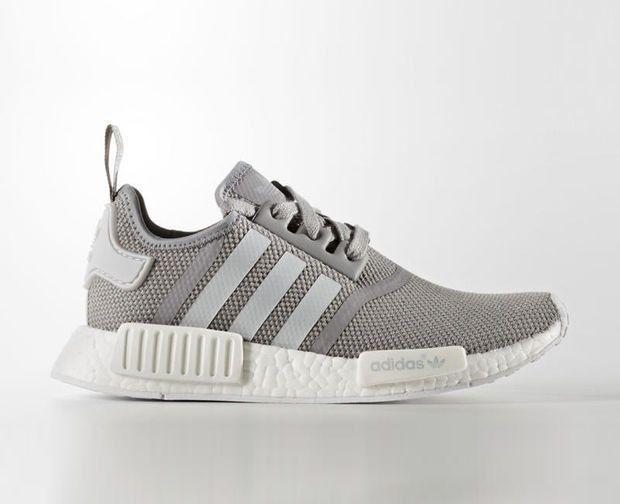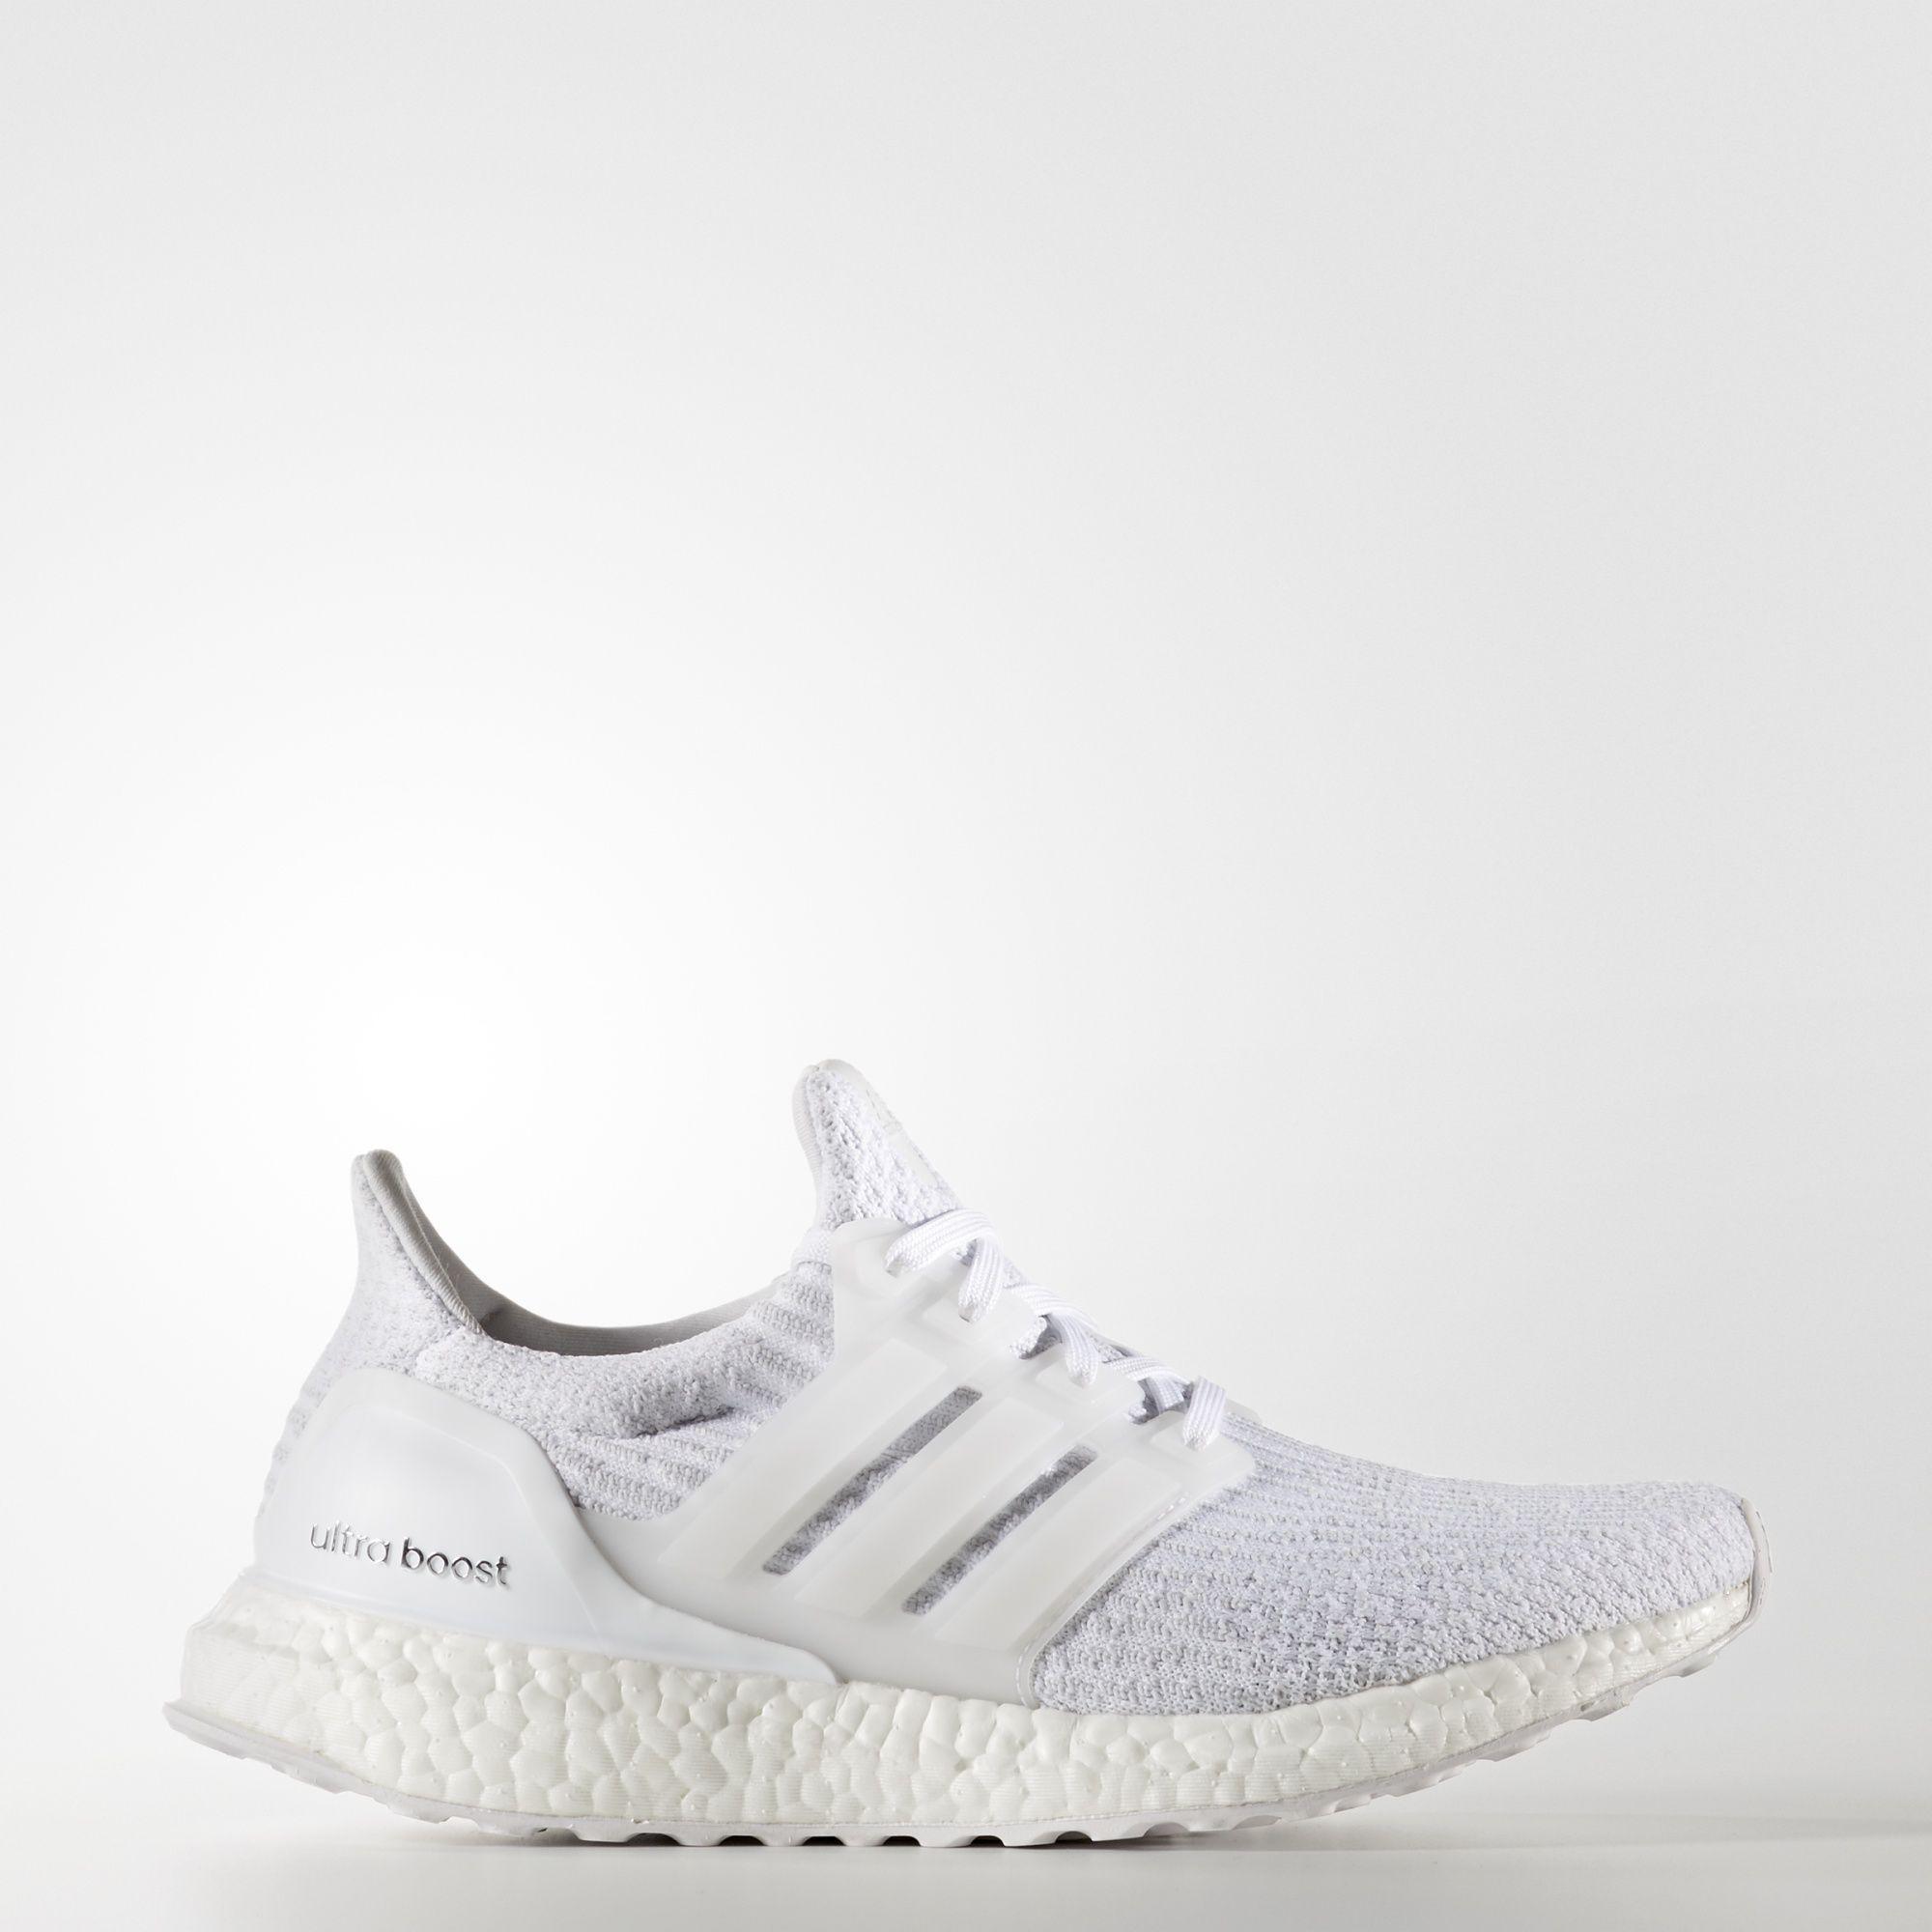The first image is the image on the left, the second image is the image on the right. Analyze the images presented: Is the assertion "In at least one image, white shoes have vertical ridges around the entire bottom of the shoe." valid? Answer yes or no. No. 